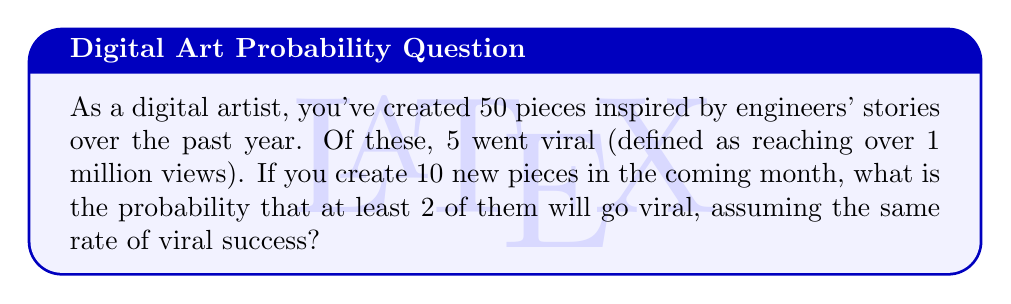Can you answer this question? Let's approach this step-by-step:

1) First, we need to calculate the probability of a single piece going viral:
   $p = \frac{\text{number of viral pieces}}{\text{total number of pieces}} = \frac{5}{50} = 0.1$ or 10%

2) Now, we're dealing with a binomial probability problem. We want to find the probability of at least 2 successes in 10 trials, where each trial has a 10% chance of success.

3) It's often easier to calculate the probability of the complement event (0 or 1 success) and subtract from 1:

   $P(\text{at least 2 viral}) = 1 - P(0 \text{ viral}) - P(1 \text{ viral})$

4) We can use the binomial probability formula:
   $P(X = k) = \binom{n}{k} p^k (1-p)^{n-k}$

   Where $n = 10$ (total pieces), $k$ is the number of successes, $p = 0.1$

5) Calculating $P(0 \text{ viral})$:
   $P(0 \text{ viral}) = \binom{10}{0} (0.1)^0 (0.9)^{10} = 1 \cdot 1 \cdot 0.3487 = 0.3487$

6) Calculating $P(1 \text{ viral})$:
   $P(1 \text{ viral}) = \binom{10}{1} (0.1)^1 (0.9)^9 = 10 \cdot 0.1 \cdot 0.3874 = 0.3874$

7) Therefore:
   $P(\text{at least 2 viral}) = 1 - 0.3487 - 0.3874 = 0.2639$
Answer: 0.2639 or approximately 26.39% 